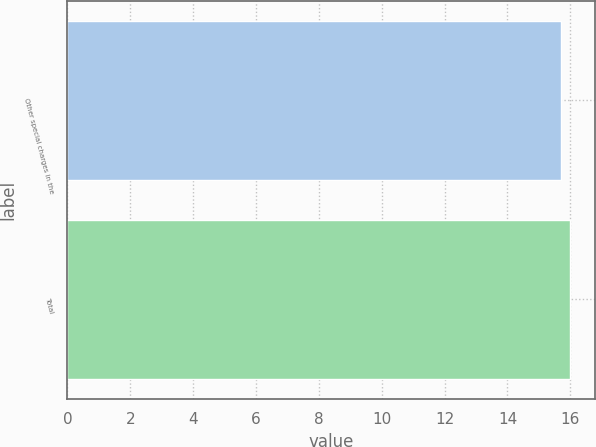<chart> <loc_0><loc_0><loc_500><loc_500><bar_chart><fcel>Other special charges in the<fcel>Total<nl><fcel>15.7<fcel>16<nl></chart> 